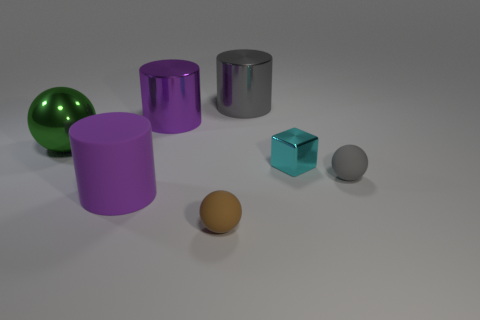What size is the green thing?
Offer a terse response. Large. Is the gray rubber object the same size as the cyan metallic thing?
Give a very brief answer. Yes. There is a thing that is both on the right side of the brown thing and behind the cyan thing; what is its color?
Provide a short and direct response. Gray. How many other things have the same material as the big gray object?
Offer a very short reply. 3. How many tiny brown metal cubes are there?
Your answer should be compact. 0. Does the gray matte sphere have the same size as the purple cylinder in front of the green sphere?
Your answer should be compact. No. There is a purple cylinder that is in front of the tiny matte object to the right of the small metallic thing; what is its material?
Offer a terse response. Rubber. What size is the rubber sphere that is behind the matte sphere that is in front of the big cylinder that is in front of the green metallic thing?
Make the answer very short. Small. There is a small gray thing; is its shape the same as the matte object to the left of the small brown ball?
Provide a succinct answer. No. What material is the large gray cylinder?
Provide a succinct answer. Metal. 